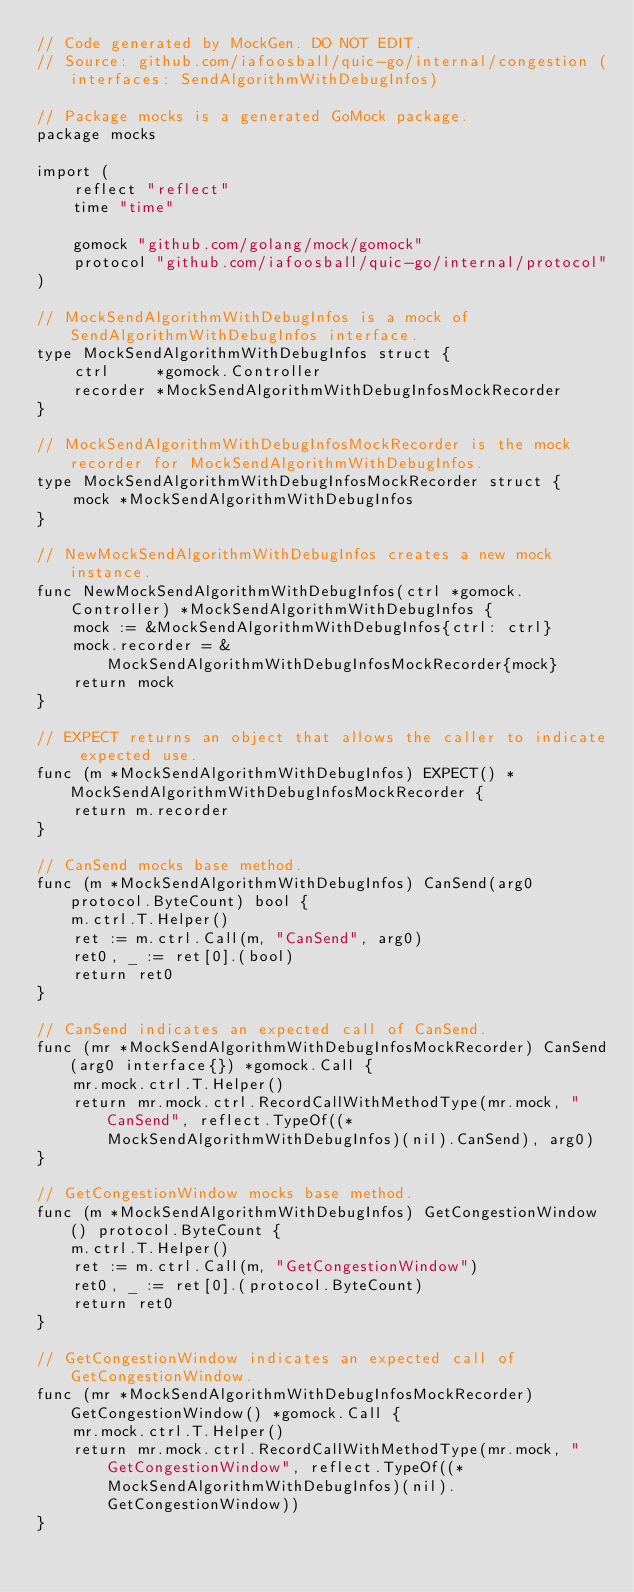<code> <loc_0><loc_0><loc_500><loc_500><_Go_>// Code generated by MockGen. DO NOT EDIT.
// Source: github.com/iafoosball/quic-go/internal/congestion (interfaces: SendAlgorithmWithDebugInfos)

// Package mocks is a generated GoMock package.
package mocks

import (
	reflect "reflect"
	time "time"

	gomock "github.com/golang/mock/gomock"
	protocol "github.com/iafoosball/quic-go/internal/protocol"
)

// MockSendAlgorithmWithDebugInfos is a mock of SendAlgorithmWithDebugInfos interface.
type MockSendAlgorithmWithDebugInfos struct {
	ctrl     *gomock.Controller
	recorder *MockSendAlgorithmWithDebugInfosMockRecorder
}

// MockSendAlgorithmWithDebugInfosMockRecorder is the mock recorder for MockSendAlgorithmWithDebugInfos.
type MockSendAlgorithmWithDebugInfosMockRecorder struct {
	mock *MockSendAlgorithmWithDebugInfos
}

// NewMockSendAlgorithmWithDebugInfos creates a new mock instance.
func NewMockSendAlgorithmWithDebugInfos(ctrl *gomock.Controller) *MockSendAlgorithmWithDebugInfos {
	mock := &MockSendAlgorithmWithDebugInfos{ctrl: ctrl}
	mock.recorder = &MockSendAlgorithmWithDebugInfosMockRecorder{mock}
	return mock
}

// EXPECT returns an object that allows the caller to indicate expected use.
func (m *MockSendAlgorithmWithDebugInfos) EXPECT() *MockSendAlgorithmWithDebugInfosMockRecorder {
	return m.recorder
}

// CanSend mocks base method.
func (m *MockSendAlgorithmWithDebugInfos) CanSend(arg0 protocol.ByteCount) bool {
	m.ctrl.T.Helper()
	ret := m.ctrl.Call(m, "CanSend", arg0)
	ret0, _ := ret[0].(bool)
	return ret0
}

// CanSend indicates an expected call of CanSend.
func (mr *MockSendAlgorithmWithDebugInfosMockRecorder) CanSend(arg0 interface{}) *gomock.Call {
	mr.mock.ctrl.T.Helper()
	return mr.mock.ctrl.RecordCallWithMethodType(mr.mock, "CanSend", reflect.TypeOf((*MockSendAlgorithmWithDebugInfos)(nil).CanSend), arg0)
}

// GetCongestionWindow mocks base method.
func (m *MockSendAlgorithmWithDebugInfos) GetCongestionWindow() protocol.ByteCount {
	m.ctrl.T.Helper()
	ret := m.ctrl.Call(m, "GetCongestionWindow")
	ret0, _ := ret[0].(protocol.ByteCount)
	return ret0
}

// GetCongestionWindow indicates an expected call of GetCongestionWindow.
func (mr *MockSendAlgorithmWithDebugInfosMockRecorder) GetCongestionWindow() *gomock.Call {
	mr.mock.ctrl.T.Helper()
	return mr.mock.ctrl.RecordCallWithMethodType(mr.mock, "GetCongestionWindow", reflect.TypeOf((*MockSendAlgorithmWithDebugInfos)(nil).GetCongestionWindow))
}
</code> 